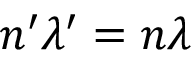Convert formula to latex. <formula><loc_0><loc_0><loc_500><loc_500>n ^ { \prime } \lambda ^ { \prime } = n \lambda</formula> 